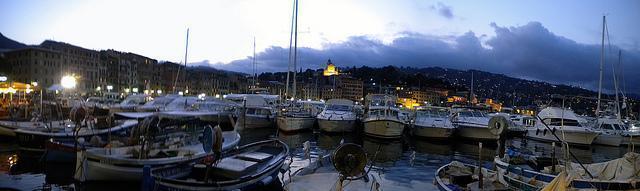What are the round objects on the boats used for?
Pick the right solution, then justify: 'Answer: answer
Rationale: rationale.'
Options: Hoisting sails, going faster, stopping suddenly, steering boat. Answer: hoisting sails.
Rationale: They move the rope lines easily. rope lines are attached to the material that catches the wind and moves the boat. 